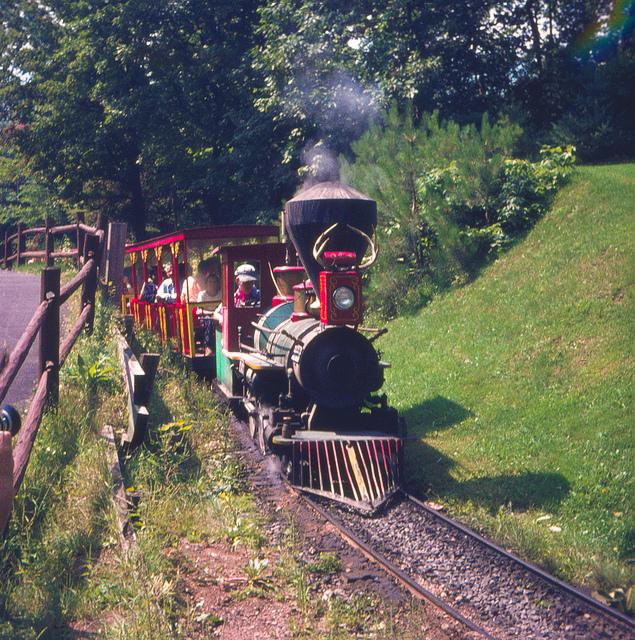What color is the train?
Quick response, please. Red. Is this a freight train?
Be succinct. No. Where is this train going?
Short answer required. In circle. 